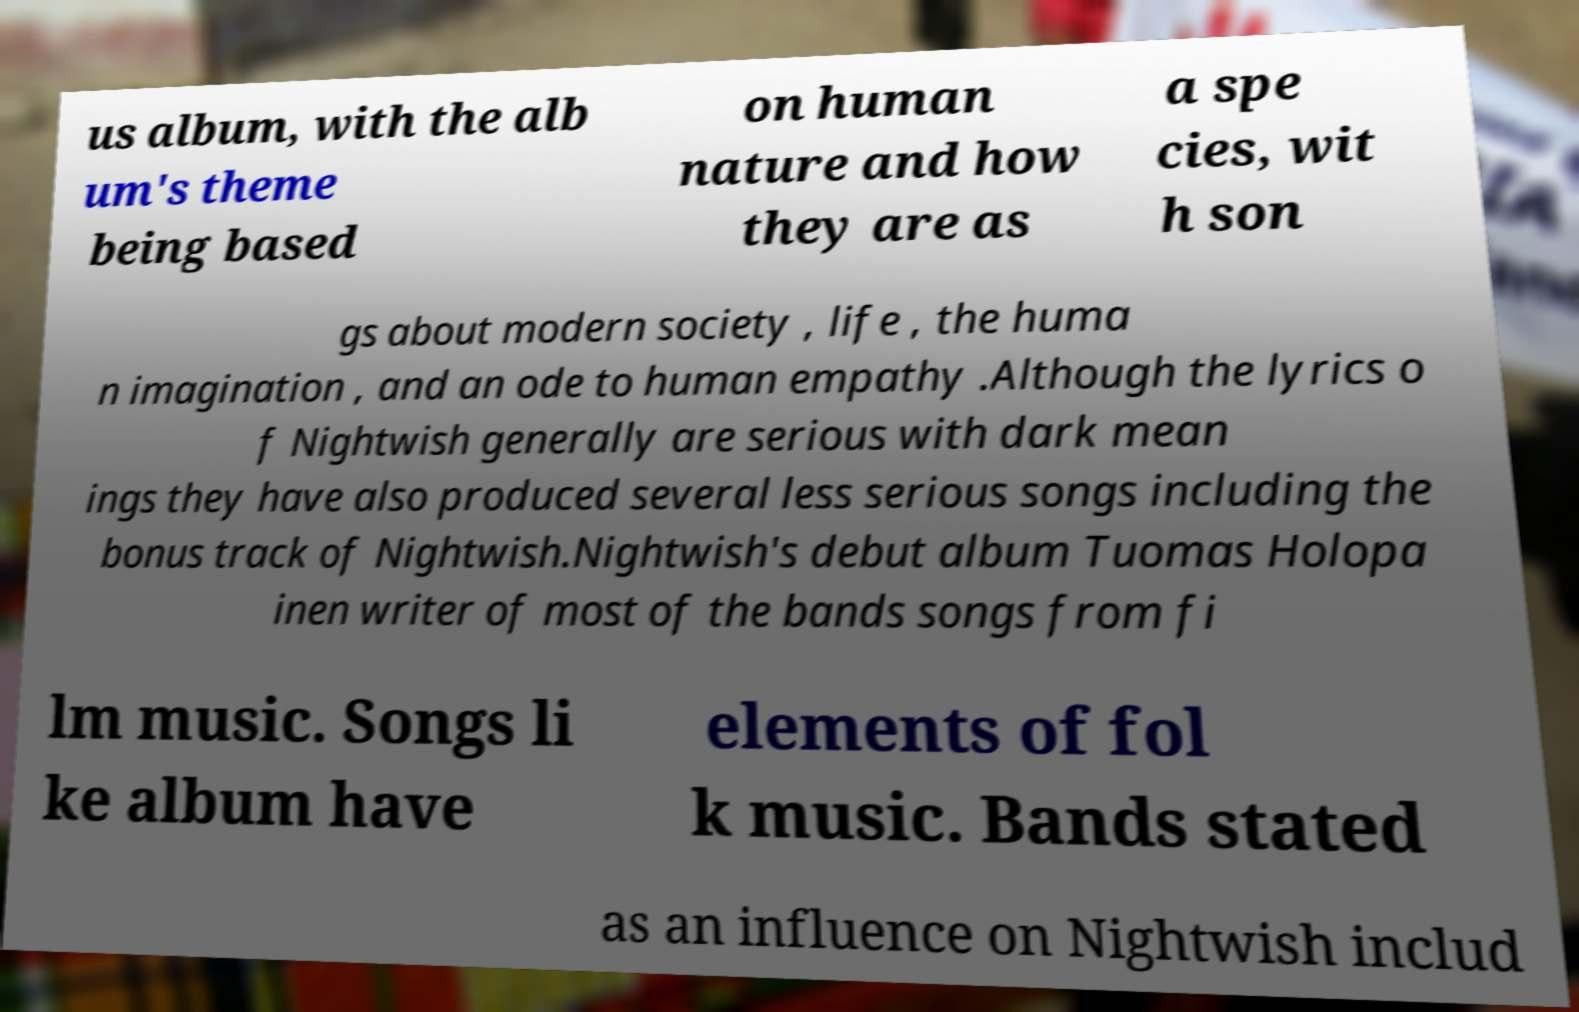For documentation purposes, I need the text within this image transcribed. Could you provide that? us album, with the alb um's theme being based on human nature and how they are as a spe cies, wit h son gs about modern society , life , the huma n imagination , and an ode to human empathy .Although the lyrics o f Nightwish generally are serious with dark mean ings they have also produced several less serious songs including the bonus track of Nightwish.Nightwish's debut album Tuomas Holopa inen writer of most of the bands songs from fi lm music. Songs li ke album have elements of fol k music. Bands stated as an influence on Nightwish includ 